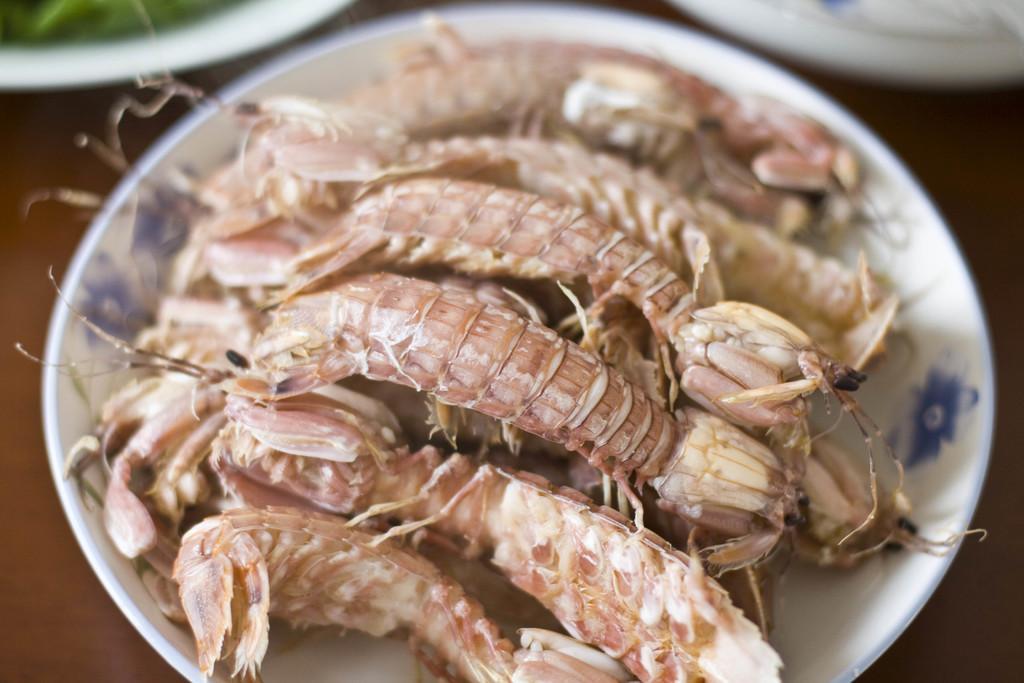Please provide a concise description of this image. This image consists of food which is on the plate in the center. 